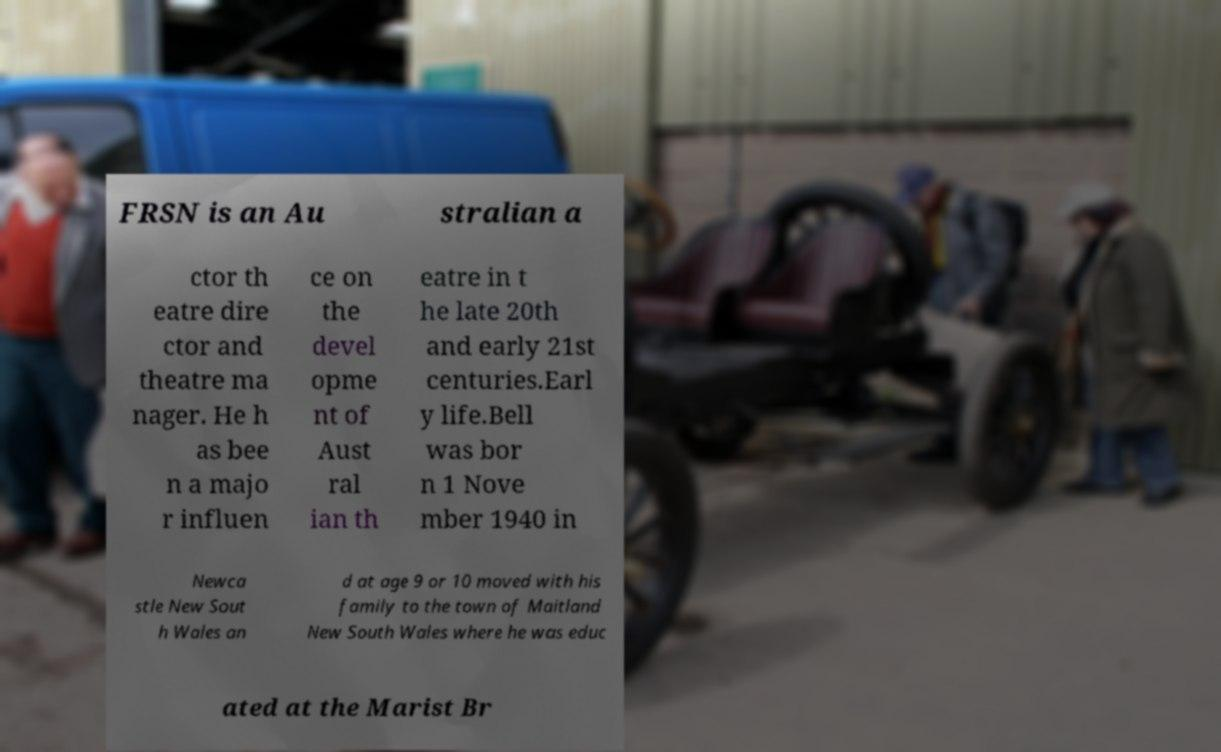What messages or text are displayed in this image? I need them in a readable, typed format. FRSN is an Au stralian a ctor th eatre dire ctor and theatre ma nager. He h as bee n a majo r influen ce on the devel opme nt of Aust ral ian th eatre in t he late 20th and early 21st centuries.Earl y life.Bell was bor n 1 Nove mber 1940 in Newca stle New Sout h Wales an d at age 9 or 10 moved with his family to the town of Maitland New South Wales where he was educ ated at the Marist Br 